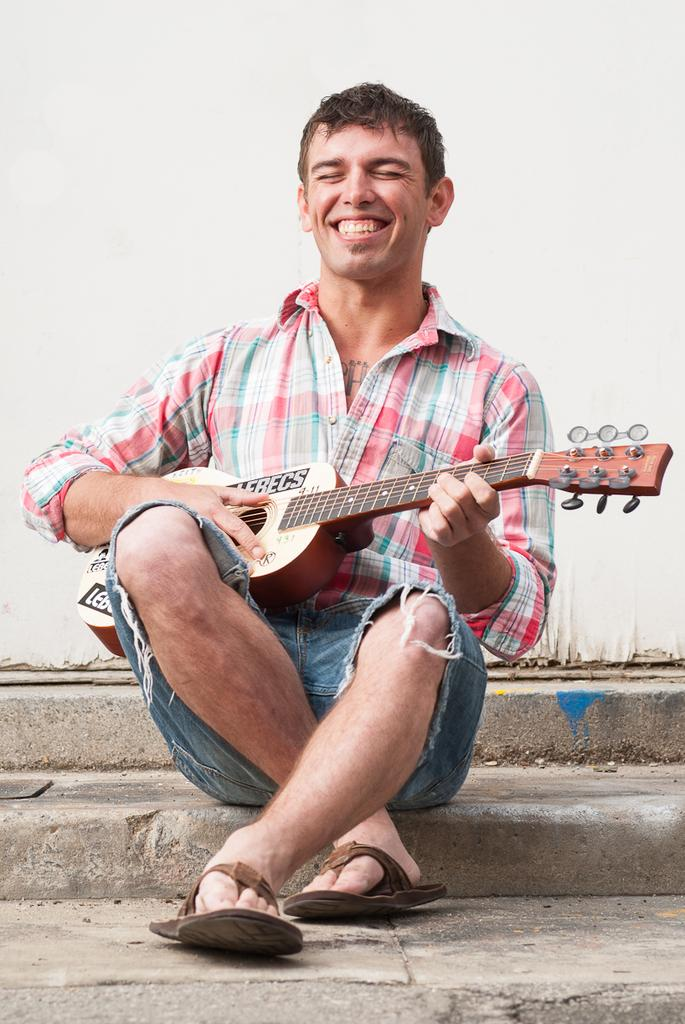What is the person in the image doing? The person is holding a guitar and giving a smile. Where is the person sitting in the image? The person is sitting on the steps. What can be seen in the background of the image? There is a white-colored wall in the background of the image. What type of board is the person using to play the guitar in the image? There is no board present in the image, and the person is not using any board to play the guitar. Who is the manager of the person playing the guitar in the image? There is no information about a manager in the image, and the person's manager is not visible or mentioned. 